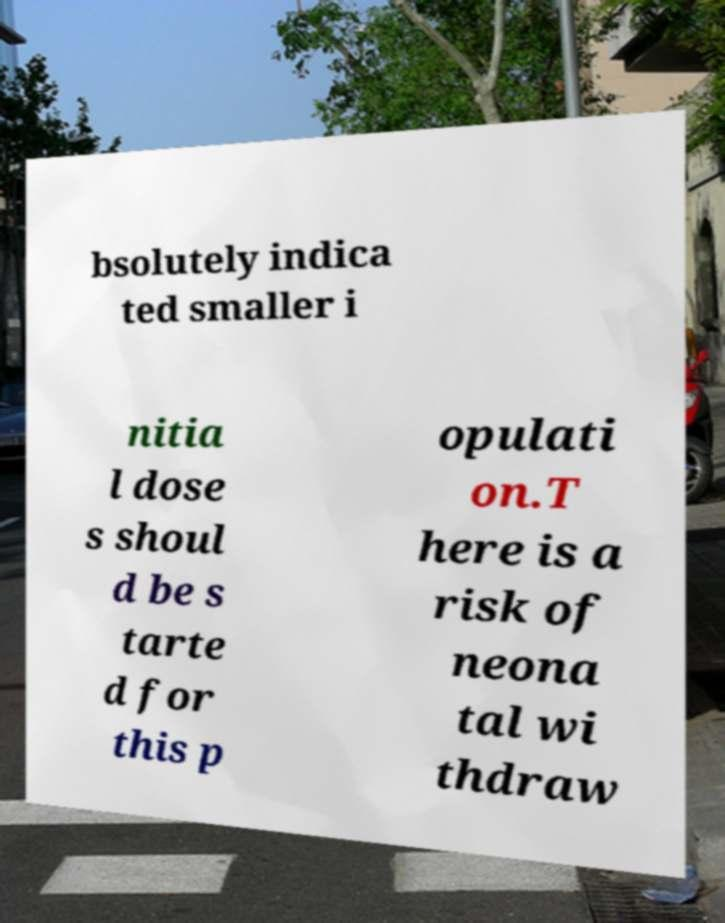Can you accurately transcribe the text from the provided image for me? bsolutely indica ted smaller i nitia l dose s shoul d be s tarte d for this p opulati on.T here is a risk of neona tal wi thdraw 